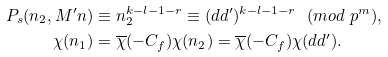<formula> <loc_0><loc_0><loc_500><loc_500>P _ { s } ( n _ { 2 } , M ^ { \prime } n ) & \equiv n _ { 2 } ^ { k - l - 1 - r } \equiv ( d d ^ { \prime } ) ^ { k - l - 1 - r } \ \ ( m o d \ p ^ { m } ) , \\ \chi ( n _ { 1 } ) & = \overline { \chi } ( - C _ { f } ) \chi ( n _ { 2 } ) = \overline { \chi } ( - C _ { f } ) \chi ( d d ^ { \prime } ) .</formula> 